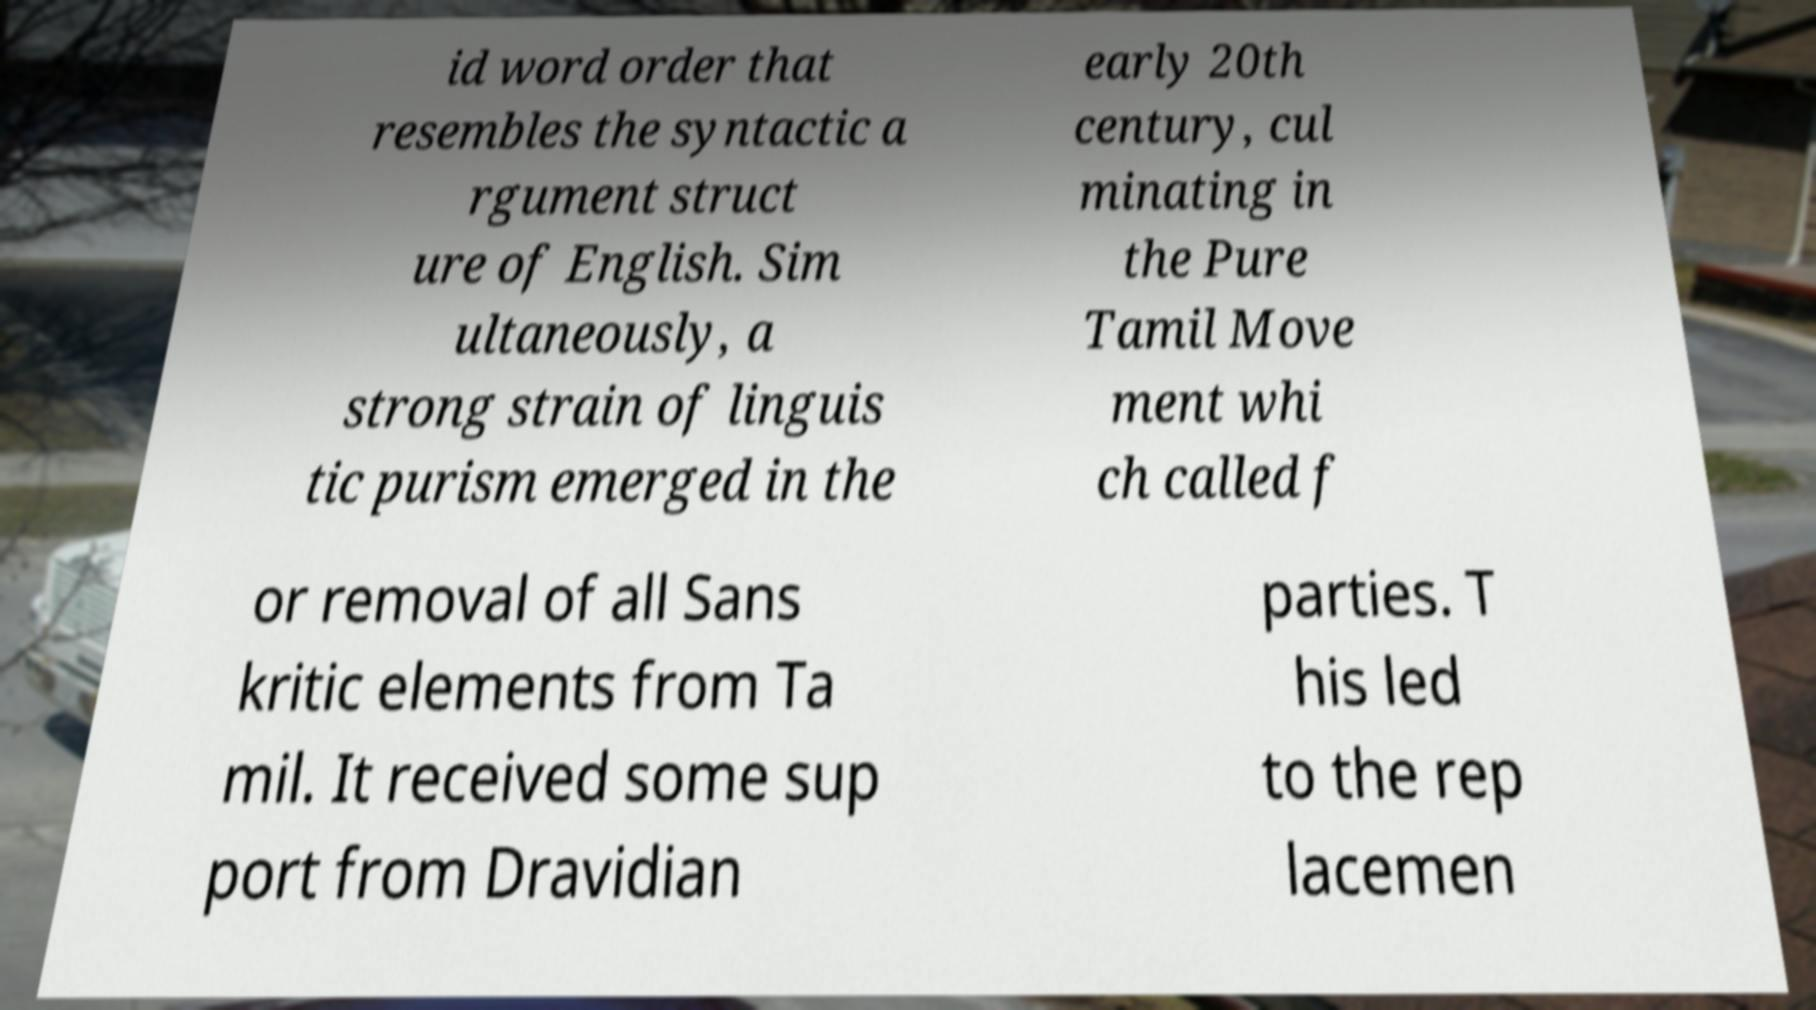I need the written content from this picture converted into text. Can you do that? id word order that resembles the syntactic a rgument struct ure of English. Sim ultaneously, a strong strain of linguis tic purism emerged in the early 20th century, cul minating in the Pure Tamil Move ment whi ch called f or removal of all Sans kritic elements from Ta mil. It received some sup port from Dravidian parties. T his led to the rep lacemen 